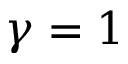<formula> <loc_0><loc_0><loc_500><loc_500>\gamma = 1</formula> 